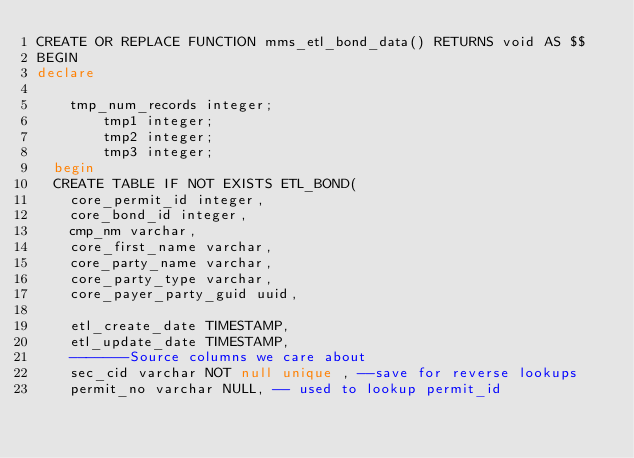Convert code to text. <code><loc_0><loc_0><loc_500><loc_500><_SQL_>CREATE OR REPLACE FUNCTION mms_etl_bond_data() RETURNS void AS $$
BEGIN
declare

		tmp_num_records integer;
        tmp1 integer;
        tmp2 integer;
        tmp3 integer;
  begin
	CREATE TABLE IF NOT EXISTS ETL_BOND(
		core_permit_id integer,
		core_bond_id integer,
		cmp_nm varchar,
		core_first_name varchar,
		core_party_name varchar,
		core_party_type varchar,
		core_payer_party_guid uuid,

		etl_create_date TIMESTAMP,
		etl_update_date TIMESTAMP,
		-------Source columns we care about
		sec_cid varchar NOT null unique , --save for reverse lookups
		permit_no varchar NULL, -- used to lookup permit_id</code> 